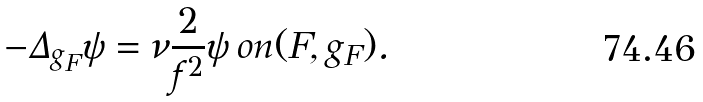<formula> <loc_0><loc_0><loc_500><loc_500>- \Delta _ { g _ { F } } \psi = \nu \frac { 2 } { f ^ { 2 } } \psi \, o n ( F , g _ { F } ) .</formula> 